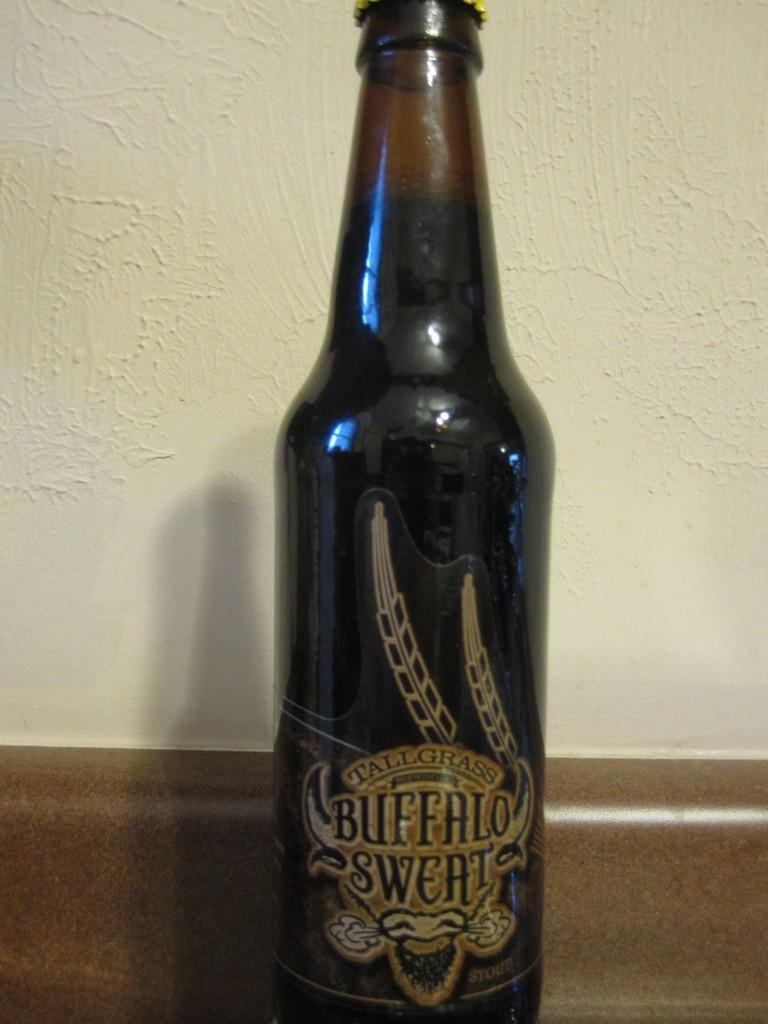Provide a one-sentence caption for the provided image. Bottle of Tallgrass Buffalo Sweat beer sitting on a table. 